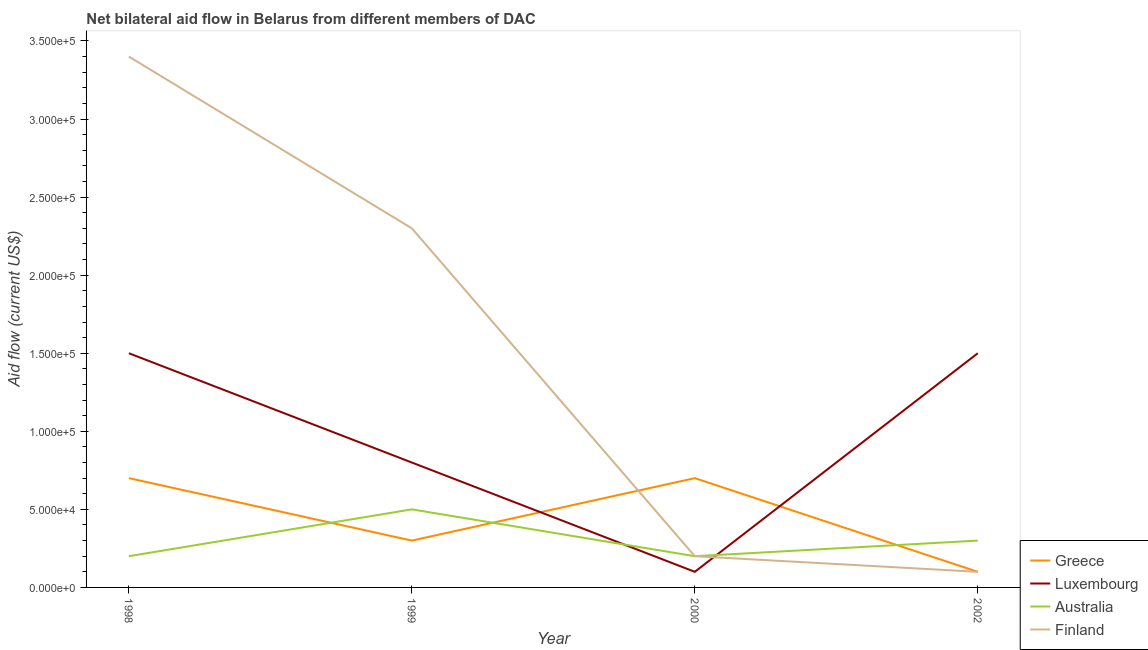Does the line corresponding to amount of aid given by finland intersect with the line corresponding to amount of aid given by greece?
Offer a very short reply. Yes. What is the amount of aid given by australia in 1998?
Ensure brevity in your answer.  2.00e+04. Across all years, what is the maximum amount of aid given by luxembourg?
Your response must be concise. 1.50e+05. Across all years, what is the minimum amount of aid given by finland?
Your answer should be compact. 10000. In which year was the amount of aid given by australia maximum?
Offer a terse response. 1999. In which year was the amount of aid given by finland minimum?
Offer a terse response. 2002. What is the total amount of aid given by australia in the graph?
Offer a very short reply. 1.20e+05. What is the difference between the amount of aid given by australia in 1998 and that in 2002?
Provide a succinct answer. -10000. What is the difference between the amount of aid given by finland in 2000 and the amount of aid given by australia in 1998?
Offer a very short reply. 0. What is the average amount of aid given by greece per year?
Your response must be concise. 4.50e+04. In the year 2000, what is the difference between the amount of aid given by finland and amount of aid given by luxembourg?
Give a very brief answer. 10000. What is the difference between the highest and the second highest amount of aid given by luxembourg?
Your answer should be compact. 0. What is the difference between the highest and the lowest amount of aid given by luxembourg?
Keep it short and to the point. 1.40e+05. Is the sum of the amount of aid given by australia in 1999 and 2000 greater than the maximum amount of aid given by greece across all years?
Keep it short and to the point. No. Is it the case that in every year, the sum of the amount of aid given by australia and amount of aid given by greece is greater than the sum of amount of aid given by finland and amount of aid given by luxembourg?
Offer a very short reply. No. Does the amount of aid given by australia monotonically increase over the years?
Keep it short and to the point. No. How many years are there in the graph?
Offer a very short reply. 4. What is the difference between two consecutive major ticks on the Y-axis?
Give a very brief answer. 5.00e+04. Does the graph contain any zero values?
Keep it short and to the point. No. Where does the legend appear in the graph?
Provide a succinct answer. Bottom right. How many legend labels are there?
Ensure brevity in your answer.  4. How are the legend labels stacked?
Give a very brief answer. Vertical. What is the title of the graph?
Offer a terse response. Net bilateral aid flow in Belarus from different members of DAC. Does "Fish species" appear as one of the legend labels in the graph?
Keep it short and to the point. No. What is the label or title of the X-axis?
Make the answer very short. Year. What is the label or title of the Y-axis?
Provide a short and direct response. Aid flow (current US$). What is the Aid flow (current US$) of Luxembourg in 1998?
Offer a terse response. 1.50e+05. What is the Aid flow (current US$) in Australia in 1999?
Your answer should be compact. 5.00e+04. What is the Aid flow (current US$) of Finland in 1999?
Make the answer very short. 2.30e+05. What is the Aid flow (current US$) in Greece in 2000?
Offer a terse response. 7.00e+04. What is the Aid flow (current US$) in Luxembourg in 2002?
Your answer should be compact. 1.50e+05. What is the Aid flow (current US$) in Finland in 2002?
Provide a succinct answer. 10000. Across all years, what is the maximum Aid flow (current US$) of Luxembourg?
Your answer should be very brief. 1.50e+05. Across all years, what is the maximum Aid flow (current US$) in Australia?
Give a very brief answer. 5.00e+04. Across all years, what is the minimum Aid flow (current US$) of Australia?
Provide a succinct answer. 2.00e+04. What is the difference between the Aid flow (current US$) in Australia in 1998 and that in 1999?
Your response must be concise. -3.00e+04. What is the difference between the Aid flow (current US$) in Finland in 1998 and that in 1999?
Provide a short and direct response. 1.10e+05. What is the difference between the Aid flow (current US$) of Greece in 1998 and that in 2000?
Ensure brevity in your answer.  0. What is the difference between the Aid flow (current US$) in Luxembourg in 1998 and that in 2000?
Your answer should be very brief. 1.40e+05. What is the difference between the Aid flow (current US$) of Finland in 1998 and that in 2000?
Your answer should be compact. 3.20e+05. What is the difference between the Aid flow (current US$) in Greece in 1998 and that in 2002?
Your answer should be very brief. 6.00e+04. What is the difference between the Aid flow (current US$) of Luxembourg in 1998 and that in 2002?
Your answer should be very brief. 0. What is the difference between the Aid flow (current US$) of Australia in 1998 and that in 2002?
Ensure brevity in your answer.  -10000. What is the difference between the Aid flow (current US$) of Greece in 1999 and that in 2000?
Offer a terse response. -4.00e+04. What is the difference between the Aid flow (current US$) of Luxembourg in 1999 and that in 2000?
Make the answer very short. 7.00e+04. What is the difference between the Aid flow (current US$) of Finland in 1999 and that in 2000?
Make the answer very short. 2.10e+05. What is the difference between the Aid flow (current US$) of Luxembourg in 1999 and that in 2002?
Offer a terse response. -7.00e+04. What is the difference between the Aid flow (current US$) of Australia in 1999 and that in 2002?
Offer a terse response. 2.00e+04. What is the difference between the Aid flow (current US$) in Finland in 1999 and that in 2002?
Give a very brief answer. 2.20e+05. What is the difference between the Aid flow (current US$) of Luxembourg in 2000 and that in 2002?
Provide a succinct answer. -1.40e+05. What is the difference between the Aid flow (current US$) in Australia in 2000 and that in 2002?
Your response must be concise. -10000. What is the difference between the Aid flow (current US$) of Greece in 1998 and the Aid flow (current US$) of Finland in 1999?
Give a very brief answer. -1.60e+05. What is the difference between the Aid flow (current US$) in Luxembourg in 1998 and the Aid flow (current US$) in Australia in 1999?
Offer a terse response. 1.00e+05. What is the difference between the Aid flow (current US$) of Luxembourg in 1998 and the Aid flow (current US$) of Finland in 1999?
Offer a terse response. -8.00e+04. What is the difference between the Aid flow (current US$) of Greece in 1998 and the Aid flow (current US$) of Australia in 2002?
Provide a short and direct response. 4.00e+04. What is the difference between the Aid flow (current US$) of Greece in 1998 and the Aid flow (current US$) of Finland in 2002?
Offer a terse response. 6.00e+04. What is the difference between the Aid flow (current US$) of Luxembourg in 1998 and the Aid flow (current US$) of Finland in 2002?
Your answer should be very brief. 1.40e+05. What is the difference between the Aid flow (current US$) of Greece in 1999 and the Aid flow (current US$) of Australia in 2000?
Your answer should be very brief. 10000. What is the difference between the Aid flow (current US$) in Australia in 1999 and the Aid flow (current US$) in Finland in 2000?
Ensure brevity in your answer.  3.00e+04. What is the difference between the Aid flow (current US$) in Greece in 1999 and the Aid flow (current US$) in Luxembourg in 2002?
Your answer should be compact. -1.20e+05. What is the difference between the Aid flow (current US$) in Greece in 1999 and the Aid flow (current US$) in Australia in 2002?
Your answer should be very brief. 0. What is the difference between the Aid flow (current US$) of Greece in 1999 and the Aid flow (current US$) of Finland in 2002?
Keep it short and to the point. 2.00e+04. What is the difference between the Aid flow (current US$) in Luxembourg in 1999 and the Aid flow (current US$) in Australia in 2002?
Provide a short and direct response. 5.00e+04. What is the difference between the Aid flow (current US$) in Luxembourg in 1999 and the Aid flow (current US$) in Finland in 2002?
Make the answer very short. 7.00e+04. What is the difference between the Aid flow (current US$) of Australia in 1999 and the Aid flow (current US$) of Finland in 2002?
Your answer should be very brief. 4.00e+04. What is the difference between the Aid flow (current US$) of Greece in 2000 and the Aid flow (current US$) of Luxembourg in 2002?
Your answer should be very brief. -8.00e+04. What is the difference between the Aid flow (current US$) in Greece in 2000 and the Aid flow (current US$) in Finland in 2002?
Make the answer very short. 6.00e+04. What is the difference between the Aid flow (current US$) of Luxembourg in 2000 and the Aid flow (current US$) of Australia in 2002?
Give a very brief answer. -2.00e+04. What is the average Aid flow (current US$) of Greece per year?
Ensure brevity in your answer.  4.50e+04. What is the average Aid flow (current US$) in Luxembourg per year?
Your answer should be very brief. 9.75e+04. What is the average Aid flow (current US$) of Finland per year?
Make the answer very short. 1.50e+05. In the year 1998, what is the difference between the Aid flow (current US$) of Greece and Aid flow (current US$) of Luxembourg?
Your answer should be compact. -8.00e+04. In the year 1998, what is the difference between the Aid flow (current US$) in Greece and Aid flow (current US$) in Australia?
Offer a terse response. 5.00e+04. In the year 1998, what is the difference between the Aid flow (current US$) in Greece and Aid flow (current US$) in Finland?
Keep it short and to the point. -2.70e+05. In the year 1998, what is the difference between the Aid flow (current US$) of Luxembourg and Aid flow (current US$) of Australia?
Offer a very short reply. 1.30e+05. In the year 1998, what is the difference between the Aid flow (current US$) of Australia and Aid flow (current US$) of Finland?
Keep it short and to the point. -3.20e+05. In the year 1999, what is the difference between the Aid flow (current US$) in Greece and Aid flow (current US$) in Luxembourg?
Your response must be concise. -5.00e+04. In the year 1999, what is the difference between the Aid flow (current US$) of Greece and Aid flow (current US$) of Australia?
Keep it short and to the point. -2.00e+04. In the year 1999, what is the difference between the Aid flow (current US$) in Luxembourg and Aid flow (current US$) in Australia?
Keep it short and to the point. 3.00e+04. In the year 2000, what is the difference between the Aid flow (current US$) in Luxembourg and Aid flow (current US$) in Finland?
Your answer should be compact. -10000. In the year 2000, what is the difference between the Aid flow (current US$) in Australia and Aid flow (current US$) in Finland?
Keep it short and to the point. 0. In the year 2002, what is the difference between the Aid flow (current US$) of Luxembourg and Aid flow (current US$) of Australia?
Offer a terse response. 1.20e+05. In the year 2002, what is the difference between the Aid flow (current US$) of Australia and Aid flow (current US$) of Finland?
Make the answer very short. 2.00e+04. What is the ratio of the Aid flow (current US$) of Greece in 1998 to that in 1999?
Keep it short and to the point. 2.33. What is the ratio of the Aid flow (current US$) of Luxembourg in 1998 to that in 1999?
Provide a succinct answer. 1.88. What is the ratio of the Aid flow (current US$) of Finland in 1998 to that in 1999?
Your answer should be very brief. 1.48. What is the ratio of the Aid flow (current US$) of Greece in 1998 to that in 2000?
Provide a short and direct response. 1. What is the ratio of the Aid flow (current US$) of Luxembourg in 1998 to that in 2000?
Give a very brief answer. 15. What is the ratio of the Aid flow (current US$) of Finland in 1998 to that in 2000?
Provide a short and direct response. 17. What is the ratio of the Aid flow (current US$) of Luxembourg in 1998 to that in 2002?
Offer a terse response. 1. What is the ratio of the Aid flow (current US$) in Finland in 1998 to that in 2002?
Give a very brief answer. 34. What is the ratio of the Aid flow (current US$) in Greece in 1999 to that in 2000?
Keep it short and to the point. 0.43. What is the ratio of the Aid flow (current US$) in Luxembourg in 1999 to that in 2000?
Your answer should be very brief. 8. What is the ratio of the Aid flow (current US$) of Australia in 1999 to that in 2000?
Offer a terse response. 2.5. What is the ratio of the Aid flow (current US$) of Finland in 1999 to that in 2000?
Ensure brevity in your answer.  11.5. What is the ratio of the Aid flow (current US$) in Greece in 1999 to that in 2002?
Your answer should be compact. 3. What is the ratio of the Aid flow (current US$) in Luxembourg in 1999 to that in 2002?
Provide a short and direct response. 0.53. What is the ratio of the Aid flow (current US$) of Finland in 1999 to that in 2002?
Give a very brief answer. 23. What is the ratio of the Aid flow (current US$) in Luxembourg in 2000 to that in 2002?
Your response must be concise. 0.07. What is the difference between the highest and the second highest Aid flow (current US$) of Greece?
Make the answer very short. 0. What is the difference between the highest and the second highest Aid flow (current US$) of Luxembourg?
Ensure brevity in your answer.  0. What is the difference between the highest and the second highest Aid flow (current US$) of Australia?
Keep it short and to the point. 2.00e+04. What is the difference between the highest and the second highest Aid flow (current US$) in Finland?
Offer a terse response. 1.10e+05. What is the difference between the highest and the lowest Aid flow (current US$) of Luxembourg?
Provide a succinct answer. 1.40e+05. What is the difference between the highest and the lowest Aid flow (current US$) of Australia?
Offer a terse response. 3.00e+04. 